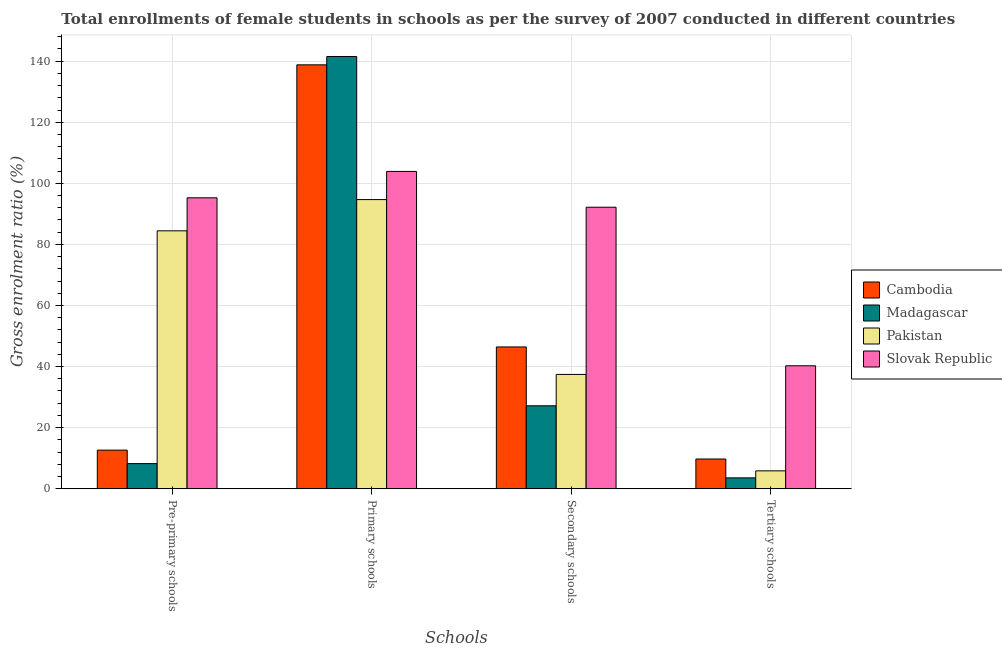How many groups of bars are there?
Make the answer very short. 4. Are the number of bars on each tick of the X-axis equal?
Your answer should be compact. Yes. How many bars are there on the 4th tick from the left?
Keep it short and to the point. 4. How many bars are there on the 4th tick from the right?
Offer a very short reply. 4. What is the label of the 3rd group of bars from the left?
Give a very brief answer. Secondary schools. What is the gross enrolment ratio(female) in pre-primary schools in Madagascar?
Keep it short and to the point. 8.21. Across all countries, what is the maximum gross enrolment ratio(female) in primary schools?
Ensure brevity in your answer.  141.55. Across all countries, what is the minimum gross enrolment ratio(female) in tertiary schools?
Offer a terse response. 3.54. In which country was the gross enrolment ratio(female) in tertiary schools maximum?
Make the answer very short. Slovak Republic. In which country was the gross enrolment ratio(female) in primary schools minimum?
Offer a terse response. Pakistan. What is the total gross enrolment ratio(female) in primary schools in the graph?
Your answer should be very brief. 478.95. What is the difference between the gross enrolment ratio(female) in pre-primary schools in Madagascar and that in Pakistan?
Make the answer very short. -76.24. What is the difference between the gross enrolment ratio(female) in tertiary schools in Pakistan and the gross enrolment ratio(female) in pre-primary schools in Madagascar?
Your answer should be compact. -2.38. What is the average gross enrolment ratio(female) in secondary schools per country?
Make the answer very short. 50.79. What is the difference between the gross enrolment ratio(female) in pre-primary schools and gross enrolment ratio(female) in tertiary schools in Pakistan?
Make the answer very short. 78.62. What is the ratio of the gross enrolment ratio(female) in primary schools in Pakistan to that in Cambodia?
Make the answer very short. 0.68. Is the gross enrolment ratio(female) in secondary schools in Slovak Republic less than that in Madagascar?
Keep it short and to the point. No. What is the difference between the highest and the second highest gross enrolment ratio(female) in primary schools?
Your answer should be very brief. 2.74. What is the difference between the highest and the lowest gross enrolment ratio(female) in secondary schools?
Keep it short and to the point. 65.03. What does the 2nd bar from the left in Tertiary schools represents?
Your answer should be compact. Madagascar. What does the 1st bar from the right in Pre-primary schools represents?
Give a very brief answer. Slovak Republic. Is it the case that in every country, the sum of the gross enrolment ratio(female) in pre-primary schools and gross enrolment ratio(female) in primary schools is greater than the gross enrolment ratio(female) in secondary schools?
Make the answer very short. Yes. How many bars are there?
Offer a terse response. 16. Are all the bars in the graph horizontal?
Your response must be concise. No. How many countries are there in the graph?
Provide a short and direct response. 4. How many legend labels are there?
Ensure brevity in your answer.  4. How are the legend labels stacked?
Ensure brevity in your answer.  Vertical. What is the title of the graph?
Give a very brief answer. Total enrollments of female students in schools as per the survey of 2007 conducted in different countries. What is the label or title of the X-axis?
Your answer should be very brief. Schools. What is the label or title of the Y-axis?
Your response must be concise. Gross enrolment ratio (%). What is the Gross enrolment ratio (%) of Cambodia in Pre-primary schools?
Provide a short and direct response. 12.63. What is the Gross enrolment ratio (%) in Madagascar in Pre-primary schools?
Give a very brief answer. 8.21. What is the Gross enrolment ratio (%) in Pakistan in Pre-primary schools?
Your answer should be compact. 84.45. What is the Gross enrolment ratio (%) in Slovak Republic in Pre-primary schools?
Offer a terse response. 95.26. What is the Gross enrolment ratio (%) in Cambodia in Primary schools?
Your answer should be very brief. 138.81. What is the Gross enrolment ratio (%) in Madagascar in Primary schools?
Your answer should be very brief. 141.55. What is the Gross enrolment ratio (%) in Pakistan in Primary schools?
Give a very brief answer. 94.68. What is the Gross enrolment ratio (%) of Slovak Republic in Primary schools?
Provide a short and direct response. 103.91. What is the Gross enrolment ratio (%) in Cambodia in Secondary schools?
Make the answer very short. 46.42. What is the Gross enrolment ratio (%) of Madagascar in Secondary schools?
Offer a very short reply. 27.15. What is the Gross enrolment ratio (%) in Pakistan in Secondary schools?
Your answer should be very brief. 37.42. What is the Gross enrolment ratio (%) of Slovak Republic in Secondary schools?
Your answer should be very brief. 92.18. What is the Gross enrolment ratio (%) in Cambodia in Tertiary schools?
Offer a very short reply. 9.72. What is the Gross enrolment ratio (%) in Madagascar in Tertiary schools?
Offer a very short reply. 3.54. What is the Gross enrolment ratio (%) of Pakistan in Tertiary schools?
Offer a very short reply. 5.84. What is the Gross enrolment ratio (%) of Slovak Republic in Tertiary schools?
Ensure brevity in your answer.  40.25. Across all Schools, what is the maximum Gross enrolment ratio (%) of Cambodia?
Make the answer very short. 138.81. Across all Schools, what is the maximum Gross enrolment ratio (%) of Madagascar?
Your response must be concise. 141.55. Across all Schools, what is the maximum Gross enrolment ratio (%) of Pakistan?
Give a very brief answer. 94.68. Across all Schools, what is the maximum Gross enrolment ratio (%) in Slovak Republic?
Your answer should be compact. 103.91. Across all Schools, what is the minimum Gross enrolment ratio (%) of Cambodia?
Your response must be concise. 9.72. Across all Schools, what is the minimum Gross enrolment ratio (%) of Madagascar?
Offer a terse response. 3.54. Across all Schools, what is the minimum Gross enrolment ratio (%) of Pakistan?
Give a very brief answer. 5.84. Across all Schools, what is the minimum Gross enrolment ratio (%) of Slovak Republic?
Your answer should be compact. 40.25. What is the total Gross enrolment ratio (%) in Cambodia in the graph?
Make the answer very short. 207.57. What is the total Gross enrolment ratio (%) in Madagascar in the graph?
Your answer should be very brief. 180.45. What is the total Gross enrolment ratio (%) in Pakistan in the graph?
Offer a very short reply. 222.39. What is the total Gross enrolment ratio (%) in Slovak Republic in the graph?
Give a very brief answer. 331.6. What is the difference between the Gross enrolment ratio (%) in Cambodia in Pre-primary schools and that in Primary schools?
Keep it short and to the point. -126.19. What is the difference between the Gross enrolment ratio (%) of Madagascar in Pre-primary schools and that in Primary schools?
Your answer should be compact. -133.33. What is the difference between the Gross enrolment ratio (%) of Pakistan in Pre-primary schools and that in Primary schools?
Your response must be concise. -10.23. What is the difference between the Gross enrolment ratio (%) of Slovak Republic in Pre-primary schools and that in Primary schools?
Offer a terse response. -8.64. What is the difference between the Gross enrolment ratio (%) in Cambodia in Pre-primary schools and that in Secondary schools?
Your response must be concise. -33.79. What is the difference between the Gross enrolment ratio (%) in Madagascar in Pre-primary schools and that in Secondary schools?
Provide a short and direct response. -18.93. What is the difference between the Gross enrolment ratio (%) of Pakistan in Pre-primary schools and that in Secondary schools?
Give a very brief answer. 47.03. What is the difference between the Gross enrolment ratio (%) in Slovak Republic in Pre-primary schools and that in Secondary schools?
Provide a short and direct response. 3.09. What is the difference between the Gross enrolment ratio (%) in Cambodia in Pre-primary schools and that in Tertiary schools?
Your answer should be very brief. 2.91. What is the difference between the Gross enrolment ratio (%) in Madagascar in Pre-primary schools and that in Tertiary schools?
Provide a succinct answer. 4.68. What is the difference between the Gross enrolment ratio (%) in Pakistan in Pre-primary schools and that in Tertiary schools?
Your answer should be very brief. 78.62. What is the difference between the Gross enrolment ratio (%) of Slovak Republic in Pre-primary schools and that in Tertiary schools?
Give a very brief answer. 55.01. What is the difference between the Gross enrolment ratio (%) in Cambodia in Primary schools and that in Secondary schools?
Keep it short and to the point. 92.39. What is the difference between the Gross enrolment ratio (%) of Madagascar in Primary schools and that in Secondary schools?
Your response must be concise. 114.4. What is the difference between the Gross enrolment ratio (%) of Pakistan in Primary schools and that in Secondary schools?
Provide a succinct answer. 57.26. What is the difference between the Gross enrolment ratio (%) of Slovak Republic in Primary schools and that in Secondary schools?
Provide a short and direct response. 11.73. What is the difference between the Gross enrolment ratio (%) of Cambodia in Primary schools and that in Tertiary schools?
Ensure brevity in your answer.  129.09. What is the difference between the Gross enrolment ratio (%) of Madagascar in Primary schools and that in Tertiary schools?
Provide a succinct answer. 138.01. What is the difference between the Gross enrolment ratio (%) in Pakistan in Primary schools and that in Tertiary schools?
Your answer should be very brief. 88.85. What is the difference between the Gross enrolment ratio (%) of Slovak Republic in Primary schools and that in Tertiary schools?
Your answer should be compact. 63.66. What is the difference between the Gross enrolment ratio (%) of Cambodia in Secondary schools and that in Tertiary schools?
Provide a short and direct response. 36.7. What is the difference between the Gross enrolment ratio (%) of Madagascar in Secondary schools and that in Tertiary schools?
Ensure brevity in your answer.  23.61. What is the difference between the Gross enrolment ratio (%) of Pakistan in Secondary schools and that in Tertiary schools?
Keep it short and to the point. 31.58. What is the difference between the Gross enrolment ratio (%) of Slovak Republic in Secondary schools and that in Tertiary schools?
Offer a terse response. 51.93. What is the difference between the Gross enrolment ratio (%) of Cambodia in Pre-primary schools and the Gross enrolment ratio (%) of Madagascar in Primary schools?
Provide a succinct answer. -128.92. What is the difference between the Gross enrolment ratio (%) in Cambodia in Pre-primary schools and the Gross enrolment ratio (%) in Pakistan in Primary schools?
Give a very brief answer. -82.06. What is the difference between the Gross enrolment ratio (%) of Cambodia in Pre-primary schools and the Gross enrolment ratio (%) of Slovak Republic in Primary schools?
Give a very brief answer. -91.28. What is the difference between the Gross enrolment ratio (%) in Madagascar in Pre-primary schools and the Gross enrolment ratio (%) in Pakistan in Primary schools?
Give a very brief answer. -86.47. What is the difference between the Gross enrolment ratio (%) of Madagascar in Pre-primary schools and the Gross enrolment ratio (%) of Slovak Republic in Primary schools?
Provide a short and direct response. -95.69. What is the difference between the Gross enrolment ratio (%) in Pakistan in Pre-primary schools and the Gross enrolment ratio (%) in Slovak Republic in Primary schools?
Your answer should be compact. -19.46. What is the difference between the Gross enrolment ratio (%) of Cambodia in Pre-primary schools and the Gross enrolment ratio (%) of Madagascar in Secondary schools?
Your answer should be very brief. -14.52. What is the difference between the Gross enrolment ratio (%) of Cambodia in Pre-primary schools and the Gross enrolment ratio (%) of Pakistan in Secondary schools?
Ensure brevity in your answer.  -24.79. What is the difference between the Gross enrolment ratio (%) in Cambodia in Pre-primary schools and the Gross enrolment ratio (%) in Slovak Republic in Secondary schools?
Your answer should be very brief. -79.55. What is the difference between the Gross enrolment ratio (%) of Madagascar in Pre-primary schools and the Gross enrolment ratio (%) of Pakistan in Secondary schools?
Offer a very short reply. -29.21. What is the difference between the Gross enrolment ratio (%) of Madagascar in Pre-primary schools and the Gross enrolment ratio (%) of Slovak Republic in Secondary schools?
Offer a very short reply. -83.96. What is the difference between the Gross enrolment ratio (%) of Pakistan in Pre-primary schools and the Gross enrolment ratio (%) of Slovak Republic in Secondary schools?
Give a very brief answer. -7.72. What is the difference between the Gross enrolment ratio (%) in Cambodia in Pre-primary schools and the Gross enrolment ratio (%) in Madagascar in Tertiary schools?
Offer a terse response. 9.09. What is the difference between the Gross enrolment ratio (%) of Cambodia in Pre-primary schools and the Gross enrolment ratio (%) of Pakistan in Tertiary schools?
Your answer should be very brief. 6.79. What is the difference between the Gross enrolment ratio (%) in Cambodia in Pre-primary schools and the Gross enrolment ratio (%) in Slovak Republic in Tertiary schools?
Your answer should be very brief. -27.62. What is the difference between the Gross enrolment ratio (%) in Madagascar in Pre-primary schools and the Gross enrolment ratio (%) in Pakistan in Tertiary schools?
Offer a terse response. 2.38. What is the difference between the Gross enrolment ratio (%) in Madagascar in Pre-primary schools and the Gross enrolment ratio (%) in Slovak Republic in Tertiary schools?
Ensure brevity in your answer.  -32.04. What is the difference between the Gross enrolment ratio (%) of Pakistan in Pre-primary schools and the Gross enrolment ratio (%) of Slovak Republic in Tertiary schools?
Make the answer very short. 44.2. What is the difference between the Gross enrolment ratio (%) in Cambodia in Primary schools and the Gross enrolment ratio (%) in Madagascar in Secondary schools?
Offer a terse response. 111.66. What is the difference between the Gross enrolment ratio (%) of Cambodia in Primary schools and the Gross enrolment ratio (%) of Pakistan in Secondary schools?
Your answer should be compact. 101.39. What is the difference between the Gross enrolment ratio (%) in Cambodia in Primary schools and the Gross enrolment ratio (%) in Slovak Republic in Secondary schools?
Your answer should be very brief. 46.63. What is the difference between the Gross enrolment ratio (%) in Madagascar in Primary schools and the Gross enrolment ratio (%) in Pakistan in Secondary schools?
Make the answer very short. 104.13. What is the difference between the Gross enrolment ratio (%) in Madagascar in Primary schools and the Gross enrolment ratio (%) in Slovak Republic in Secondary schools?
Make the answer very short. 49.37. What is the difference between the Gross enrolment ratio (%) in Pakistan in Primary schools and the Gross enrolment ratio (%) in Slovak Republic in Secondary schools?
Your answer should be very brief. 2.5. What is the difference between the Gross enrolment ratio (%) in Cambodia in Primary schools and the Gross enrolment ratio (%) in Madagascar in Tertiary schools?
Ensure brevity in your answer.  135.27. What is the difference between the Gross enrolment ratio (%) of Cambodia in Primary schools and the Gross enrolment ratio (%) of Pakistan in Tertiary schools?
Offer a terse response. 132.98. What is the difference between the Gross enrolment ratio (%) of Cambodia in Primary schools and the Gross enrolment ratio (%) of Slovak Republic in Tertiary schools?
Keep it short and to the point. 98.56. What is the difference between the Gross enrolment ratio (%) of Madagascar in Primary schools and the Gross enrolment ratio (%) of Pakistan in Tertiary schools?
Your answer should be compact. 135.71. What is the difference between the Gross enrolment ratio (%) in Madagascar in Primary schools and the Gross enrolment ratio (%) in Slovak Republic in Tertiary schools?
Provide a succinct answer. 101.3. What is the difference between the Gross enrolment ratio (%) in Pakistan in Primary schools and the Gross enrolment ratio (%) in Slovak Republic in Tertiary schools?
Ensure brevity in your answer.  54.43. What is the difference between the Gross enrolment ratio (%) of Cambodia in Secondary schools and the Gross enrolment ratio (%) of Madagascar in Tertiary schools?
Give a very brief answer. 42.88. What is the difference between the Gross enrolment ratio (%) of Cambodia in Secondary schools and the Gross enrolment ratio (%) of Pakistan in Tertiary schools?
Keep it short and to the point. 40.58. What is the difference between the Gross enrolment ratio (%) in Cambodia in Secondary schools and the Gross enrolment ratio (%) in Slovak Republic in Tertiary schools?
Offer a very short reply. 6.17. What is the difference between the Gross enrolment ratio (%) in Madagascar in Secondary schools and the Gross enrolment ratio (%) in Pakistan in Tertiary schools?
Offer a very short reply. 21.31. What is the difference between the Gross enrolment ratio (%) in Madagascar in Secondary schools and the Gross enrolment ratio (%) in Slovak Republic in Tertiary schools?
Offer a terse response. -13.1. What is the difference between the Gross enrolment ratio (%) in Pakistan in Secondary schools and the Gross enrolment ratio (%) in Slovak Republic in Tertiary schools?
Provide a succinct answer. -2.83. What is the average Gross enrolment ratio (%) of Cambodia per Schools?
Provide a short and direct response. 51.89. What is the average Gross enrolment ratio (%) in Madagascar per Schools?
Your response must be concise. 45.11. What is the average Gross enrolment ratio (%) in Pakistan per Schools?
Provide a short and direct response. 55.6. What is the average Gross enrolment ratio (%) in Slovak Republic per Schools?
Your response must be concise. 82.9. What is the difference between the Gross enrolment ratio (%) of Cambodia and Gross enrolment ratio (%) of Madagascar in Pre-primary schools?
Make the answer very short. 4.41. What is the difference between the Gross enrolment ratio (%) of Cambodia and Gross enrolment ratio (%) of Pakistan in Pre-primary schools?
Your answer should be compact. -71.83. What is the difference between the Gross enrolment ratio (%) of Cambodia and Gross enrolment ratio (%) of Slovak Republic in Pre-primary schools?
Provide a succinct answer. -82.64. What is the difference between the Gross enrolment ratio (%) in Madagascar and Gross enrolment ratio (%) in Pakistan in Pre-primary schools?
Your answer should be very brief. -76.24. What is the difference between the Gross enrolment ratio (%) in Madagascar and Gross enrolment ratio (%) in Slovak Republic in Pre-primary schools?
Your response must be concise. -87.05. What is the difference between the Gross enrolment ratio (%) of Pakistan and Gross enrolment ratio (%) of Slovak Republic in Pre-primary schools?
Offer a terse response. -10.81. What is the difference between the Gross enrolment ratio (%) in Cambodia and Gross enrolment ratio (%) in Madagascar in Primary schools?
Make the answer very short. -2.74. What is the difference between the Gross enrolment ratio (%) of Cambodia and Gross enrolment ratio (%) of Pakistan in Primary schools?
Offer a terse response. 44.13. What is the difference between the Gross enrolment ratio (%) in Cambodia and Gross enrolment ratio (%) in Slovak Republic in Primary schools?
Give a very brief answer. 34.9. What is the difference between the Gross enrolment ratio (%) in Madagascar and Gross enrolment ratio (%) in Pakistan in Primary schools?
Ensure brevity in your answer.  46.87. What is the difference between the Gross enrolment ratio (%) in Madagascar and Gross enrolment ratio (%) in Slovak Republic in Primary schools?
Ensure brevity in your answer.  37.64. What is the difference between the Gross enrolment ratio (%) of Pakistan and Gross enrolment ratio (%) of Slovak Republic in Primary schools?
Offer a very short reply. -9.23. What is the difference between the Gross enrolment ratio (%) in Cambodia and Gross enrolment ratio (%) in Madagascar in Secondary schools?
Your answer should be compact. 19.27. What is the difference between the Gross enrolment ratio (%) in Cambodia and Gross enrolment ratio (%) in Pakistan in Secondary schools?
Your answer should be very brief. 9. What is the difference between the Gross enrolment ratio (%) in Cambodia and Gross enrolment ratio (%) in Slovak Republic in Secondary schools?
Offer a terse response. -45.76. What is the difference between the Gross enrolment ratio (%) in Madagascar and Gross enrolment ratio (%) in Pakistan in Secondary schools?
Offer a very short reply. -10.27. What is the difference between the Gross enrolment ratio (%) in Madagascar and Gross enrolment ratio (%) in Slovak Republic in Secondary schools?
Give a very brief answer. -65.03. What is the difference between the Gross enrolment ratio (%) in Pakistan and Gross enrolment ratio (%) in Slovak Republic in Secondary schools?
Give a very brief answer. -54.76. What is the difference between the Gross enrolment ratio (%) in Cambodia and Gross enrolment ratio (%) in Madagascar in Tertiary schools?
Your answer should be very brief. 6.18. What is the difference between the Gross enrolment ratio (%) in Cambodia and Gross enrolment ratio (%) in Pakistan in Tertiary schools?
Keep it short and to the point. 3.88. What is the difference between the Gross enrolment ratio (%) of Cambodia and Gross enrolment ratio (%) of Slovak Republic in Tertiary schools?
Provide a short and direct response. -30.53. What is the difference between the Gross enrolment ratio (%) of Madagascar and Gross enrolment ratio (%) of Pakistan in Tertiary schools?
Your answer should be compact. -2.3. What is the difference between the Gross enrolment ratio (%) in Madagascar and Gross enrolment ratio (%) in Slovak Republic in Tertiary schools?
Offer a very short reply. -36.71. What is the difference between the Gross enrolment ratio (%) in Pakistan and Gross enrolment ratio (%) in Slovak Republic in Tertiary schools?
Your answer should be compact. -34.41. What is the ratio of the Gross enrolment ratio (%) of Cambodia in Pre-primary schools to that in Primary schools?
Your answer should be very brief. 0.09. What is the ratio of the Gross enrolment ratio (%) of Madagascar in Pre-primary schools to that in Primary schools?
Provide a succinct answer. 0.06. What is the ratio of the Gross enrolment ratio (%) of Pakistan in Pre-primary schools to that in Primary schools?
Keep it short and to the point. 0.89. What is the ratio of the Gross enrolment ratio (%) in Slovak Republic in Pre-primary schools to that in Primary schools?
Offer a very short reply. 0.92. What is the ratio of the Gross enrolment ratio (%) of Cambodia in Pre-primary schools to that in Secondary schools?
Your answer should be very brief. 0.27. What is the ratio of the Gross enrolment ratio (%) of Madagascar in Pre-primary schools to that in Secondary schools?
Provide a short and direct response. 0.3. What is the ratio of the Gross enrolment ratio (%) in Pakistan in Pre-primary schools to that in Secondary schools?
Provide a succinct answer. 2.26. What is the ratio of the Gross enrolment ratio (%) in Slovak Republic in Pre-primary schools to that in Secondary schools?
Keep it short and to the point. 1.03. What is the ratio of the Gross enrolment ratio (%) in Cambodia in Pre-primary schools to that in Tertiary schools?
Provide a succinct answer. 1.3. What is the ratio of the Gross enrolment ratio (%) in Madagascar in Pre-primary schools to that in Tertiary schools?
Offer a very short reply. 2.32. What is the ratio of the Gross enrolment ratio (%) in Pakistan in Pre-primary schools to that in Tertiary schools?
Provide a short and direct response. 14.47. What is the ratio of the Gross enrolment ratio (%) in Slovak Republic in Pre-primary schools to that in Tertiary schools?
Provide a short and direct response. 2.37. What is the ratio of the Gross enrolment ratio (%) in Cambodia in Primary schools to that in Secondary schools?
Make the answer very short. 2.99. What is the ratio of the Gross enrolment ratio (%) in Madagascar in Primary schools to that in Secondary schools?
Offer a very short reply. 5.21. What is the ratio of the Gross enrolment ratio (%) in Pakistan in Primary schools to that in Secondary schools?
Offer a terse response. 2.53. What is the ratio of the Gross enrolment ratio (%) in Slovak Republic in Primary schools to that in Secondary schools?
Offer a terse response. 1.13. What is the ratio of the Gross enrolment ratio (%) in Cambodia in Primary schools to that in Tertiary schools?
Your response must be concise. 14.29. What is the ratio of the Gross enrolment ratio (%) in Madagascar in Primary schools to that in Tertiary schools?
Make the answer very short. 40. What is the ratio of the Gross enrolment ratio (%) of Pakistan in Primary schools to that in Tertiary schools?
Make the answer very short. 16.23. What is the ratio of the Gross enrolment ratio (%) in Slovak Republic in Primary schools to that in Tertiary schools?
Offer a very short reply. 2.58. What is the ratio of the Gross enrolment ratio (%) in Cambodia in Secondary schools to that in Tertiary schools?
Provide a short and direct response. 4.78. What is the ratio of the Gross enrolment ratio (%) in Madagascar in Secondary schools to that in Tertiary schools?
Provide a succinct answer. 7.67. What is the ratio of the Gross enrolment ratio (%) of Pakistan in Secondary schools to that in Tertiary schools?
Your answer should be compact. 6.41. What is the ratio of the Gross enrolment ratio (%) in Slovak Republic in Secondary schools to that in Tertiary schools?
Make the answer very short. 2.29. What is the difference between the highest and the second highest Gross enrolment ratio (%) in Cambodia?
Ensure brevity in your answer.  92.39. What is the difference between the highest and the second highest Gross enrolment ratio (%) in Madagascar?
Ensure brevity in your answer.  114.4. What is the difference between the highest and the second highest Gross enrolment ratio (%) of Pakistan?
Your answer should be compact. 10.23. What is the difference between the highest and the second highest Gross enrolment ratio (%) in Slovak Republic?
Make the answer very short. 8.64. What is the difference between the highest and the lowest Gross enrolment ratio (%) of Cambodia?
Offer a very short reply. 129.09. What is the difference between the highest and the lowest Gross enrolment ratio (%) in Madagascar?
Your answer should be compact. 138.01. What is the difference between the highest and the lowest Gross enrolment ratio (%) of Pakistan?
Keep it short and to the point. 88.85. What is the difference between the highest and the lowest Gross enrolment ratio (%) in Slovak Republic?
Your answer should be very brief. 63.66. 